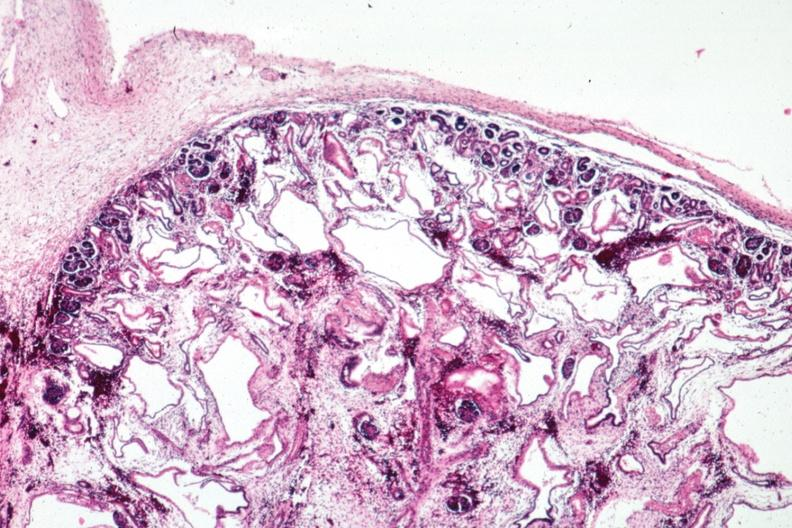s kidney present?
Answer the question using a single word or phrase. Yes 